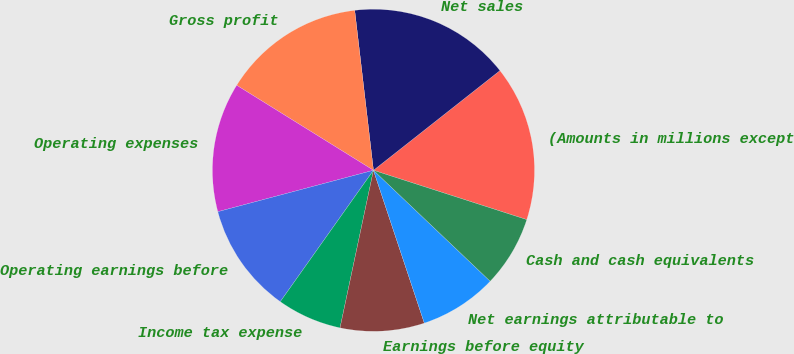Convert chart to OTSL. <chart><loc_0><loc_0><loc_500><loc_500><pie_chart><fcel>(Amounts in millions except<fcel>Net sales<fcel>Gross profit<fcel>Operating expenses<fcel>Operating earnings before<fcel>Income tax expense<fcel>Earnings before equity<fcel>Net earnings attributable to<fcel>Cash and cash equivalents<nl><fcel>15.58%<fcel>16.23%<fcel>14.29%<fcel>12.99%<fcel>11.04%<fcel>6.49%<fcel>8.44%<fcel>7.79%<fcel>7.14%<nl></chart> 